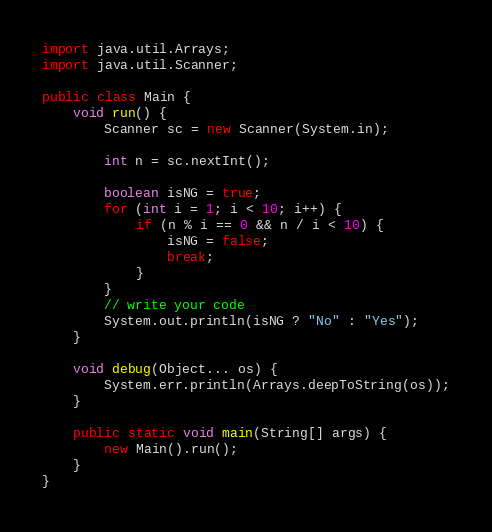Convert code to text. <code><loc_0><loc_0><loc_500><loc_500><_Java_>
import java.util.Arrays;
import java.util.Scanner;

public class Main {
    void run() {
        Scanner sc = new Scanner(System.in);

        int n = sc.nextInt();

        boolean isNG = true;
        for (int i = 1; i < 10; i++) {
            if (n % i == 0 && n / i < 10) {
                isNG = false;
                break;
            }
        }
        // write your code
        System.out.println(isNG ? "No" : "Yes");
    }

    void debug(Object... os) {
        System.err.println(Arrays.deepToString(os));
    }

    public static void main(String[] args) {
        new Main().run();
    }
}
</code> 